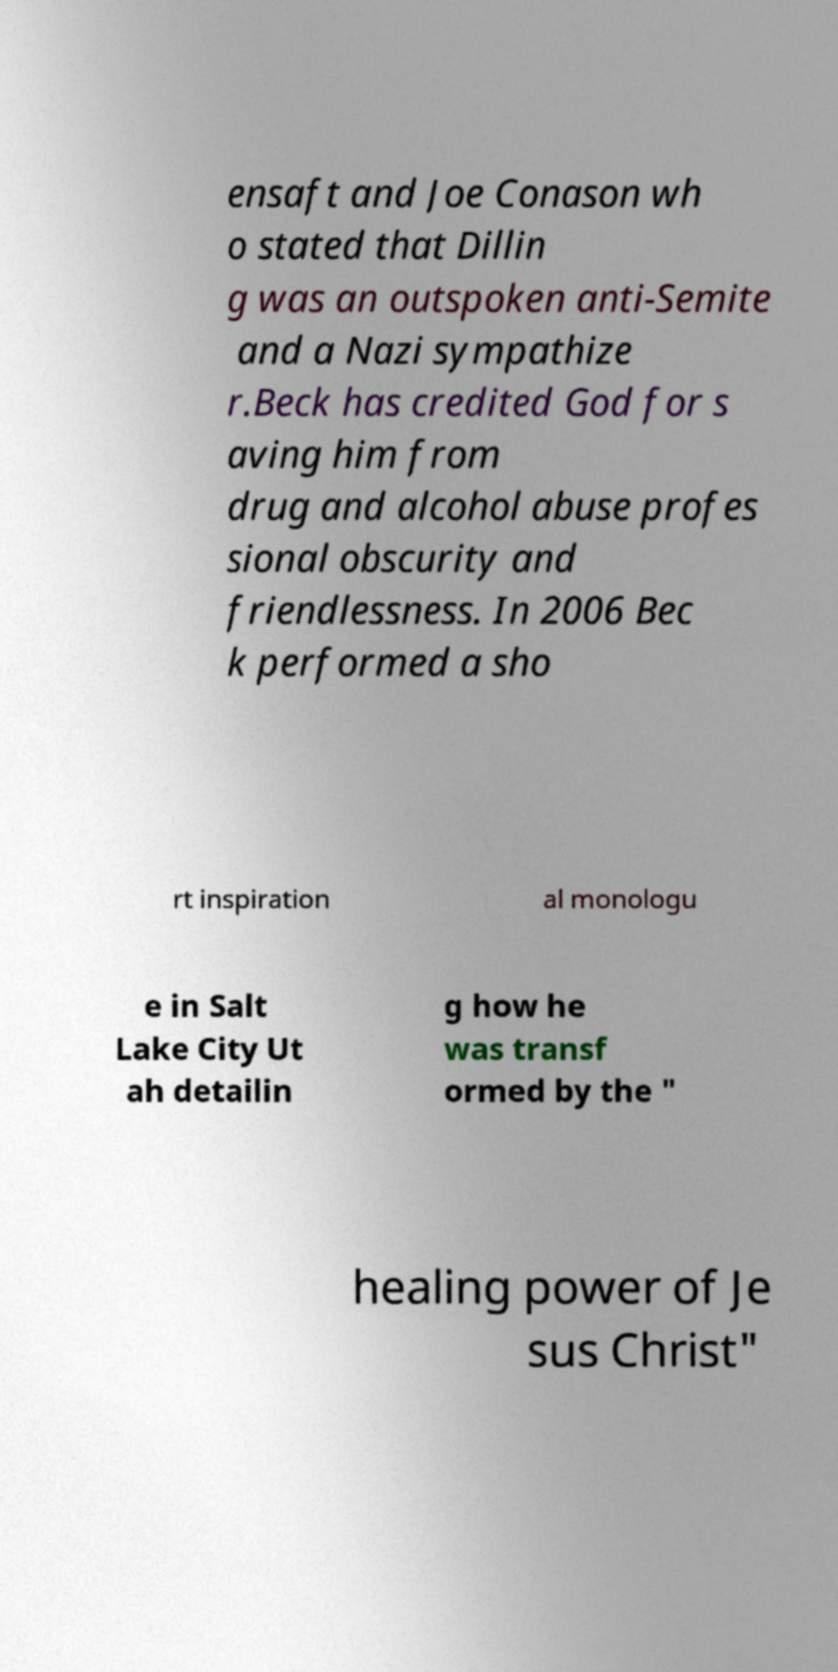What messages or text are displayed in this image? I need them in a readable, typed format. ensaft and Joe Conason wh o stated that Dillin g was an outspoken anti-Semite and a Nazi sympathize r.Beck has credited God for s aving him from drug and alcohol abuse profes sional obscurity and friendlessness. In 2006 Bec k performed a sho rt inspiration al monologu e in Salt Lake City Ut ah detailin g how he was transf ormed by the " healing power of Je sus Christ" 